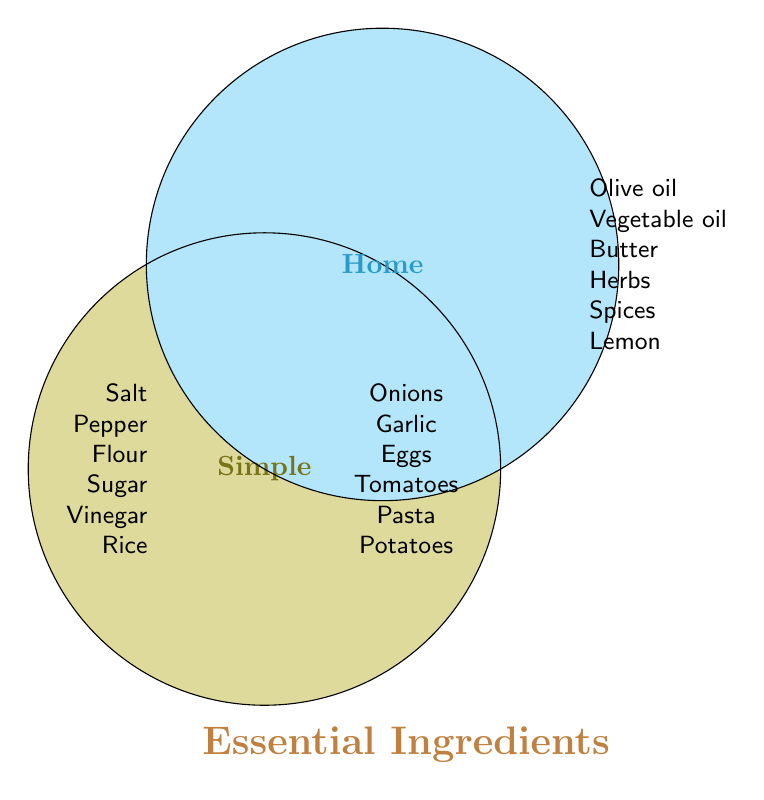What are the ingredients listed under 'Simple'? The ingredients under 'Simple' are those on the left side of the diagram. They are Salt, Pepper, Flour, Sugar, Vinegar, and Rice.
Answer: Salt, Pepper, Flour, Sugar, Vinegar, Rice What are the shared ingredients in the center of the diagram? The ingredients in the center of the Venn Diagram are those that belong to both 'Simple' and 'Home'. They are Onions, Garlic, Eggs, Tomatoes, Pasta, and Potatoes.
Answer: Onions, Garlic, Eggs, Tomatoes, Pasta, Potatoes Which side has more unique ingredients, 'Simple' or 'Home'? To find which side has more unique ingredients, count the items on each side excluding the center. 'Simple' has 6 and 'Home' also has 6 unique ingredients. So, both have the same number.
Answer: Both have the same number How many total ingredients are there in the 'Home' category? To find the total number of ingredients in the 'Home' category, sum the unique ingredients in 'Home' (6) and the shared ingredients in the center (6). Thus, the total is 6 + 6 = 12.
Answer: 12 Are there any ingredients in the diagram that do not fall into any home cooking category? All ingredients listed in the diagram either fall into 'Simple', 'Home', or both categories. Therefore, there are no ingredients that do not fall into any category.
Answer: No Which ingredients are common between 'Simple' and 'Home'? The common ingredients between 'Simple' and 'Home' are in the intersection of the Venn Diagram. They are Onions, Garlic, Eggs, Tomatoes, Pasta, and Potatoes.
Answer: Onions, Garlic, Eggs, Tomatoes, Pasta, Potatoes Which section contains Olive oil? Olive oil is listed in the 'Home' category, on the right side of the diagram.
Answer: Home How many ingredients are only found in the 'Simple' category? The 'Simple' category has 6 unique ingredients excluding the shared center.
Answer: 6 Is Lemon considered a 'Simple' ingredient, a 'Home' ingredient, or both? Lemon is listed in the 'Home' category, on the right side of the diagram, so it is only an ingredient in the 'Home' category.
Answer: Home 